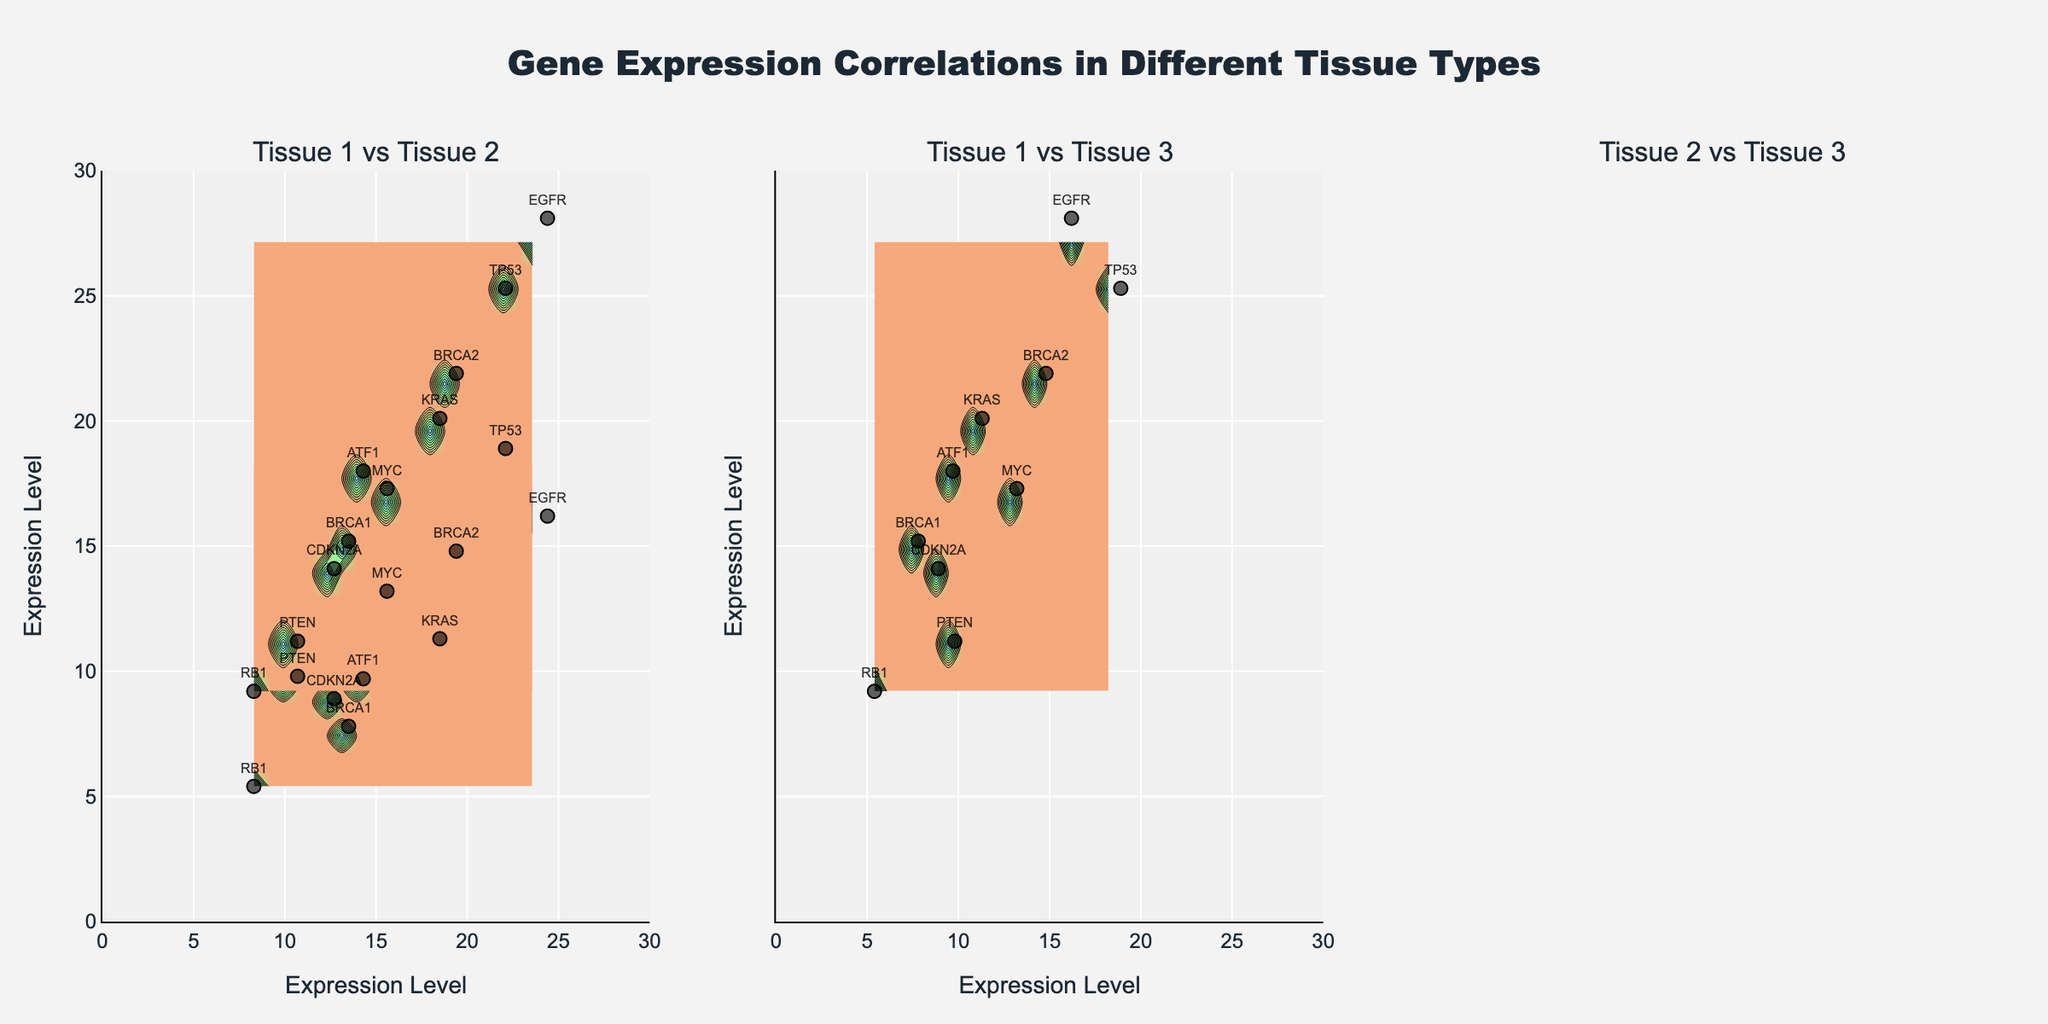What is the title of the figure? The title of the figure is displayed at the top center and reads "Gene Expression Correlations in Different Tissue Types".
Answer: Gene Expression Correlations in Different Tissue Types How many subplots are there in the figure? The figure contains three subplots arranged in a single row, as indicated by the three subplot titles.
Answer: 3 What is the x-axis label for each subplot? The x-axis label for each subplot is "Expression Level", which can be observed below each of the x-axes.
Answer: Expression Level What is the highest expression level observed in Tissue 1? From the scatter plots, the highest expression level in Tissue 1 can be seen in the gene EGFR, which has a value of 24.4.
Answer: 24.4 Which gene has the highest expression in Tissue 2? By checking the scatter plots, TP53 shows the highest expression level in Tissue 2 with a value of 18.9.
Answer: TP53 What is the range of the y-axis in each subplot? The range of the y-axis in each subplot spans from 0 to 30, consistent across all subplots as indicated by the y-axis labels.
Answer: 0 to 30 How are the colors used in the contour plots? The colors in the contour plots represent different levels of gene expression densities, transitioning from lighter to darker shades within the provided color scale.
Answer: Levels of gene expression densities For how many tissue comparisons is the BRCA1 gene shown? BRCA1 is shown in all three tissue comparisons: Tissue 1 vs Tissue 2, Tissue 1 vs Tissue 3, and Tissue 2 vs Tissue 3, as it is one of the genes annotated in the scatter plots across all subplots.
Answer: 3 What's the correlation trend between Tissue 1 and Tissue 3? The scatter plot and contour for Tissue 1 vs Tissue 3 indicate a positive correlation, as higher expression levels in Tissue 1 are associated with higher expression levels in Tissue 3.
Answer: Positive correlation Are there any genes with similar expression levels across all three tissues? Yes, by visually inspecting the data points and text annotations, MYC has similar expression levels across all three tissues (15.6 in Tissue 1, 13.2 in Tissue 2, and 17.3 in Tissue 3).
Answer: MYC 